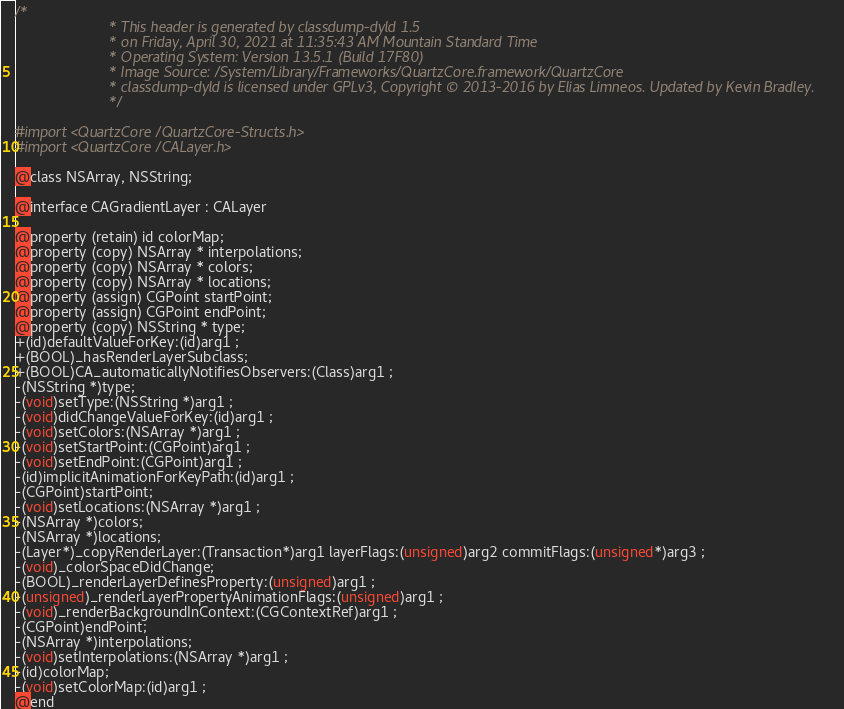<code> <loc_0><loc_0><loc_500><loc_500><_C_>/*
                       * This header is generated by classdump-dyld 1.5
                       * on Friday, April 30, 2021 at 11:35:43 AM Mountain Standard Time
                       * Operating System: Version 13.5.1 (Build 17F80)
                       * Image Source: /System/Library/Frameworks/QuartzCore.framework/QuartzCore
                       * classdump-dyld is licensed under GPLv3, Copyright © 2013-2016 by Elias Limneos. Updated by Kevin Bradley.
                       */

#import <QuartzCore/QuartzCore-Structs.h>
#import <QuartzCore/CALayer.h>

@class NSArray, NSString;

@interface CAGradientLayer : CALayer

@property (retain) id colorMap; 
@property (copy) NSArray * interpolations; 
@property (copy) NSArray * colors; 
@property (copy) NSArray * locations; 
@property (assign) CGPoint startPoint; 
@property (assign) CGPoint endPoint; 
@property (copy) NSString * type; 
+(id)defaultValueForKey:(id)arg1 ;
+(BOOL)_hasRenderLayerSubclass;
+(BOOL)CA_automaticallyNotifiesObservers:(Class)arg1 ;
-(NSString *)type;
-(void)setType:(NSString *)arg1 ;
-(void)didChangeValueForKey:(id)arg1 ;
-(void)setColors:(NSArray *)arg1 ;
-(void)setStartPoint:(CGPoint)arg1 ;
-(void)setEndPoint:(CGPoint)arg1 ;
-(id)implicitAnimationForKeyPath:(id)arg1 ;
-(CGPoint)startPoint;
-(void)setLocations:(NSArray *)arg1 ;
-(NSArray *)colors;
-(NSArray *)locations;
-(Layer*)_copyRenderLayer:(Transaction*)arg1 layerFlags:(unsigned)arg2 commitFlags:(unsigned*)arg3 ;
-(void)_colorSpaceDidChange;
-(BOOL)_renderLayerDefinesProperty:(unsigned)arg1 ;
-(unsigned)_renderLayerPropertyAnimationFlags:(unsigned)arg1 ;
-(void)_renderBackgroundInContext:(CGContextRef)arg1 ;
-(CGPoint)endPoint;
-(NSArray *)interpolations;
-(void)setInterpolations:(NSArray *)arg1 ;
-(id)colorMap;
-(void)setColorMap:(id)arg1 ;
@end

</code> 